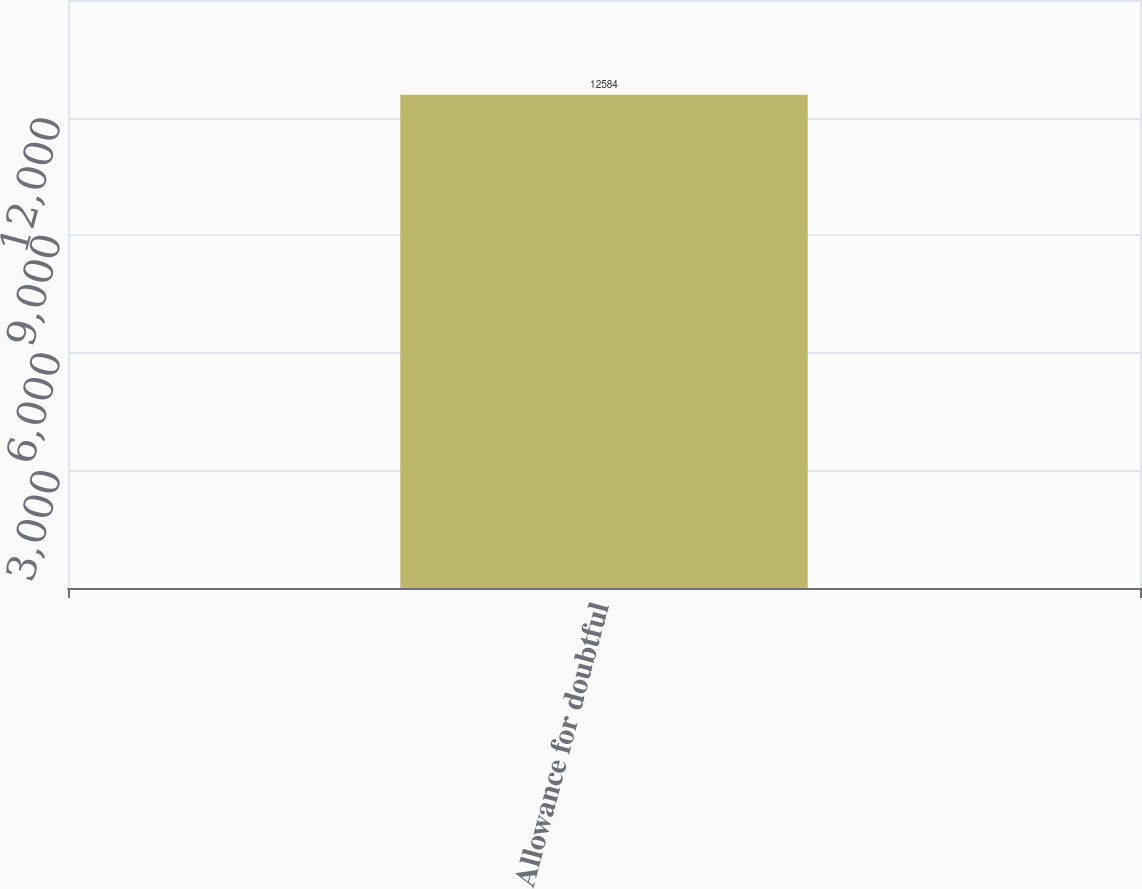Convert chart. <chart><loc_0><loc_0><loc_500><loc_500><bar_chart><fcel>Allowance for doubtful<nl><fcel>12584<nl></chart> 